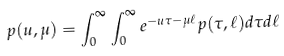Convert formula to latex. <formula><loc_0><loc_0><loc_500><loc_500>p ( u , \mu ) = \int _ { 0 } ^ { \infty } \int _ { 0 } ^ { \infty } e ^ { - u \tau - \mu \ell } p ( \tau , \ell ) d \tau d \ell</formula> 